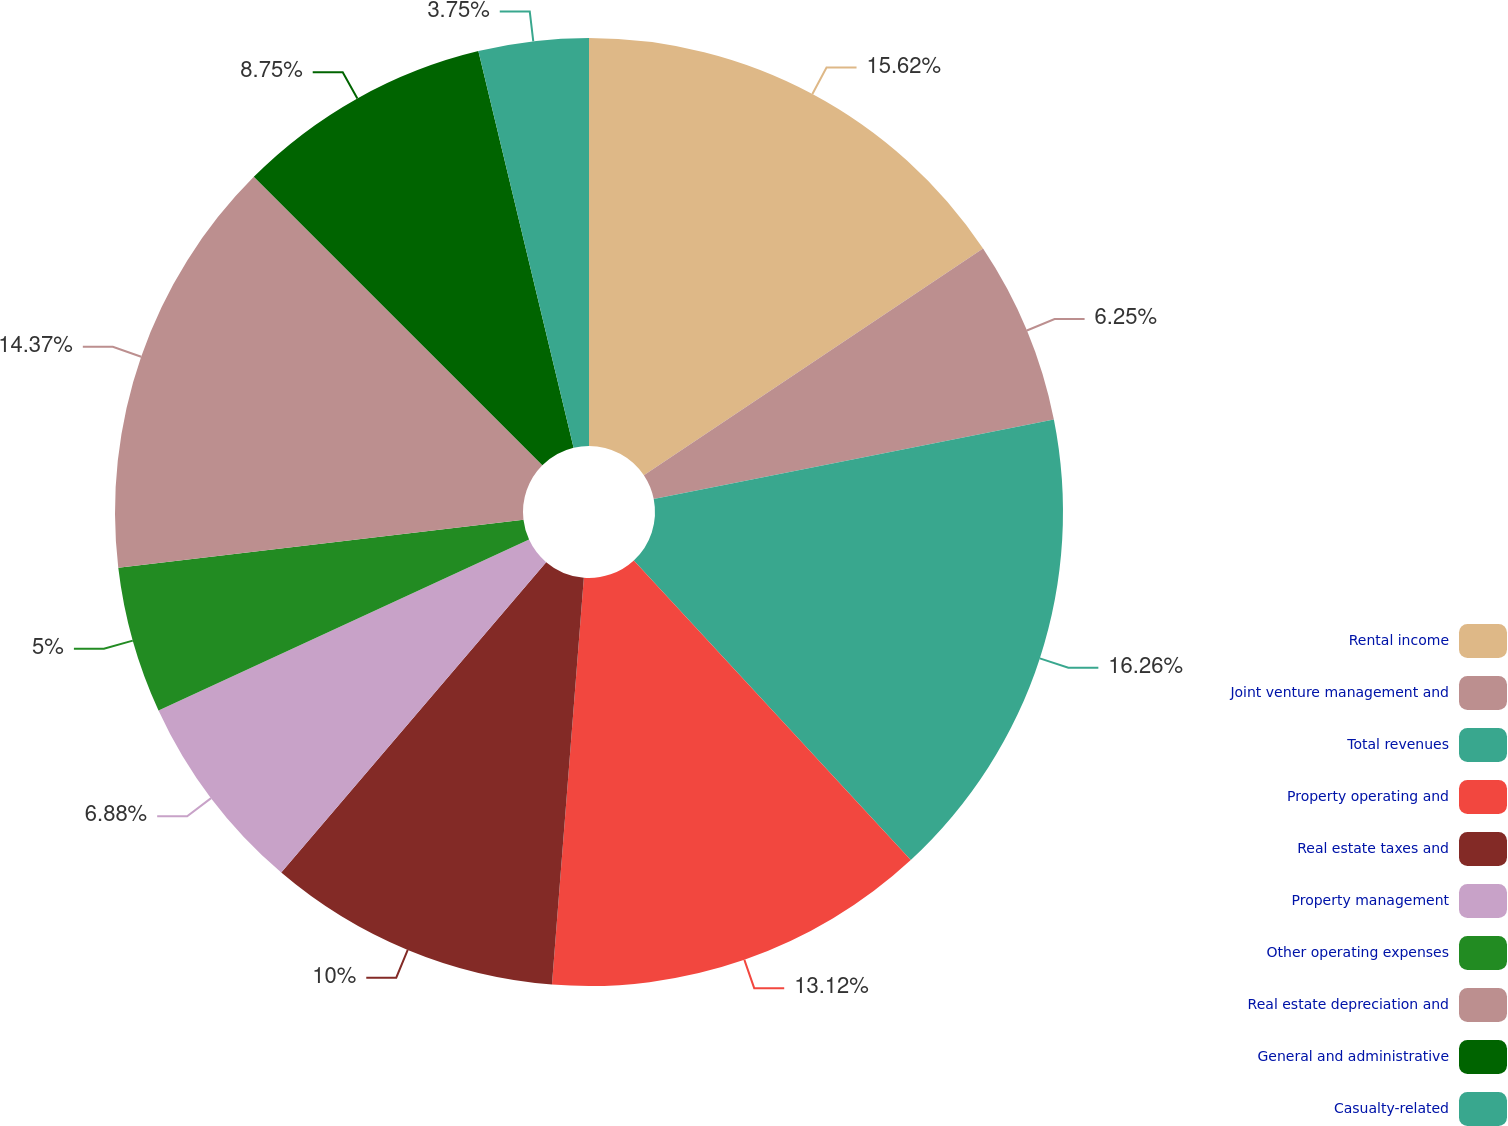Convert chart. <chart><loc_0><loc_0><loc_500><loc_500><pie_chart><fcel>Rental income<fcel>Joint venture management and<fcel>Total revenues<fcel>Property operating and<fcel>Real estate taxes and<fcel>Property management<fcel>Other operating expenses<fcel>Real estate depreciation and<fcel>General and administrative<fcel>Casualty-related<nl><fcel>15.62%<fcel>6.25%<fcel>16.25%<fcel>13.12%<fcel>10.0%<fcel>6.88%<fcel>5.0%<fcel>14.37%<fcel>8.75%<fcel>3.75%<nl></chart> 